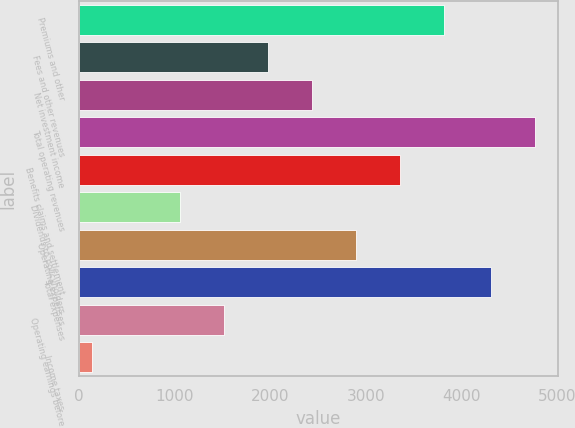Convert chart. <chart><loc_0><loc_0><loc_500><loc_500><bar_chart><fcel>Premiums and other<fcel>Fees and other revenues<fcel>Net investment income<fcel>Total operating revenues<fcel>Benefits claims and settlement<fcel>Dividends to policyholders<fcel>Operating expenses<fcel>Total expenses<fcel>Operating earnings before<fcel>Income taxes<nl><fcel>3817.42<fcel>1979.86<fcel>2439.25<fcel>4770.79<fcel>3358.03<fcel>1061.08<fcel>2898.64<fcel>4311.4<fcel>1520.47<fcel>142.3<nl></chart> 